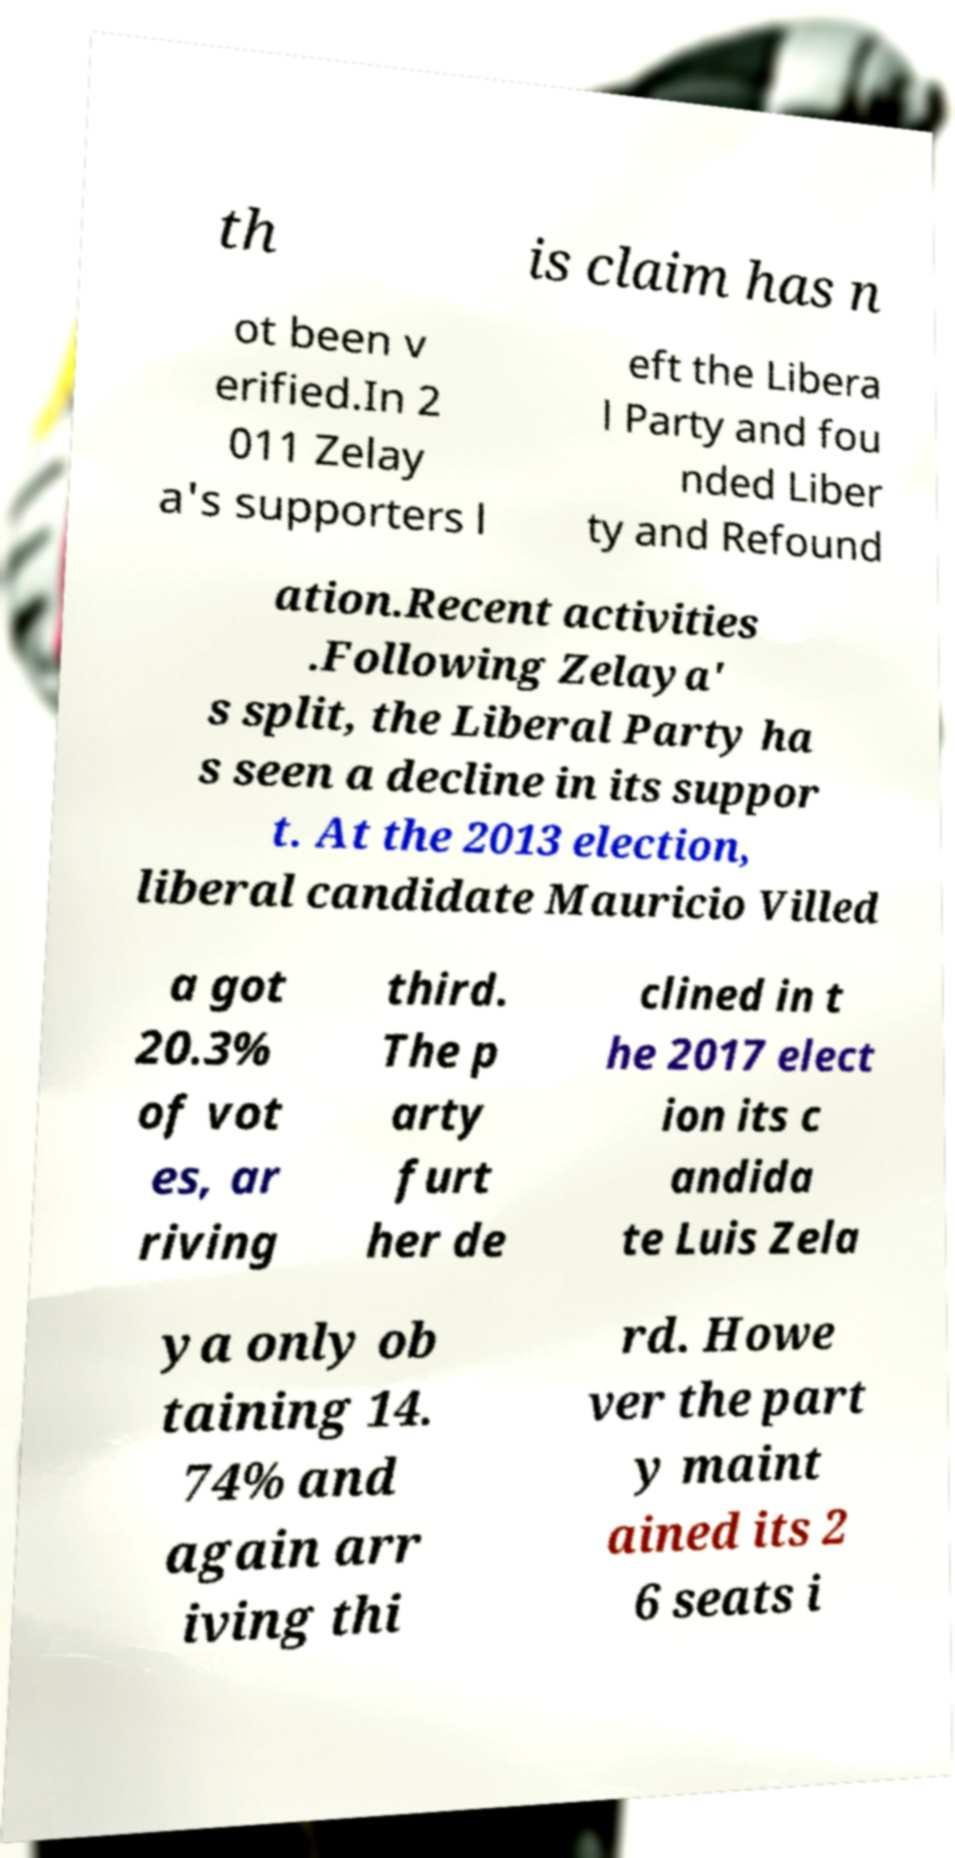Could you extract and type out the text from this image? th is claim has n ot been v erified.In 2 011 Zelay a's supporters l eft the Libera l Party and fou nded Liber ty and Refound ation.Recent activities .Following Zelaya' s split, the Liberal Party ha s seen a decline in its suppor t. At the 2013 election, liberal candidate Mauricio Villed a got 20.3% of vot es, ar riving third. The p arty furt her de clined in t he 2017 elect ion its c andida te Luis Zela ya only ob taining 14. 74% and again arr iving thi rd. Howe ver the part y maint ained its 2 6 seats i 